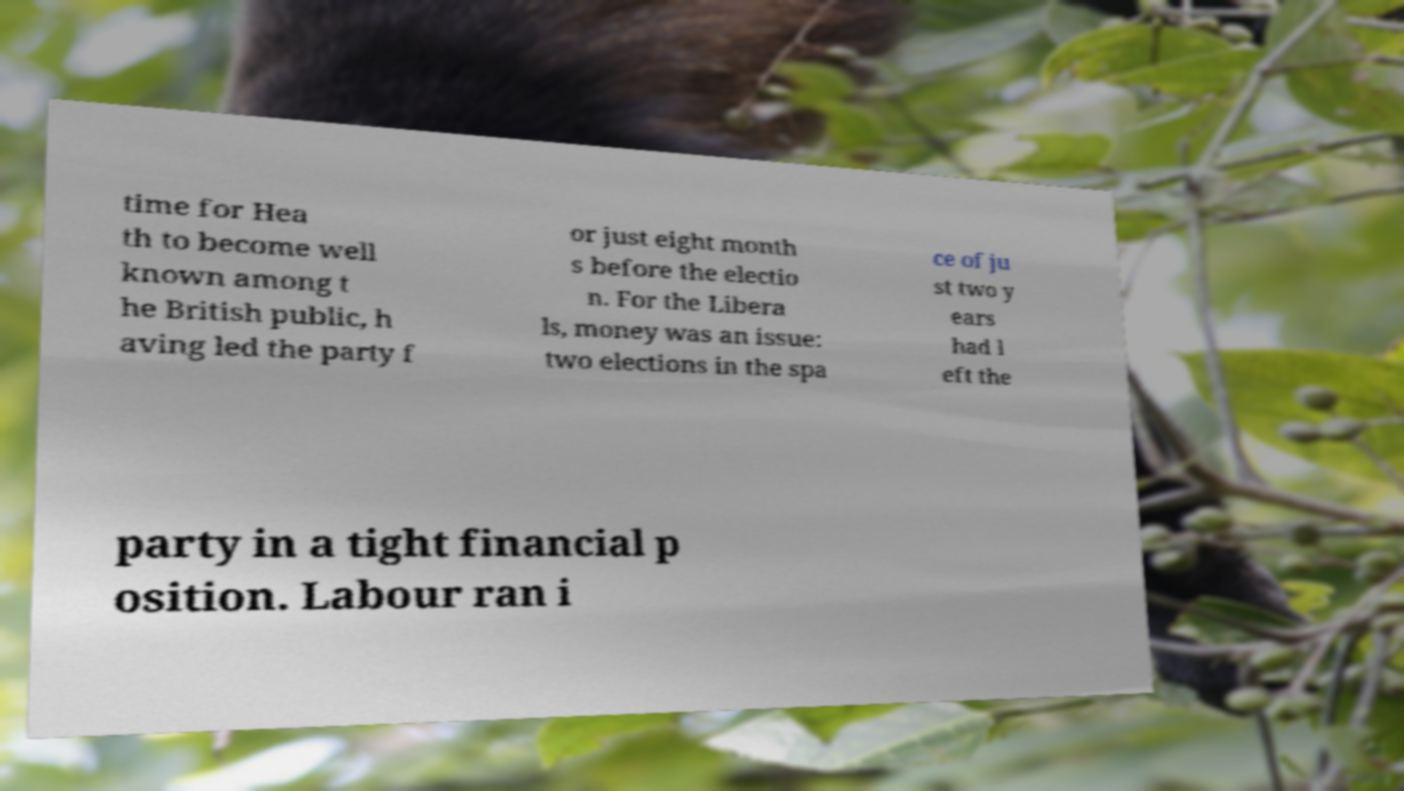For documentation purposes, I need the text within this image transcribed. Could you provide that? time for Hea th to become well known among t he British public, h aving led the party f or just eight month s before the electio n. For the Libera ls, money was an issue: two elections in the spa ce of ju st two y ears had l eft the party in a tight financial p osition. Labour ran i 